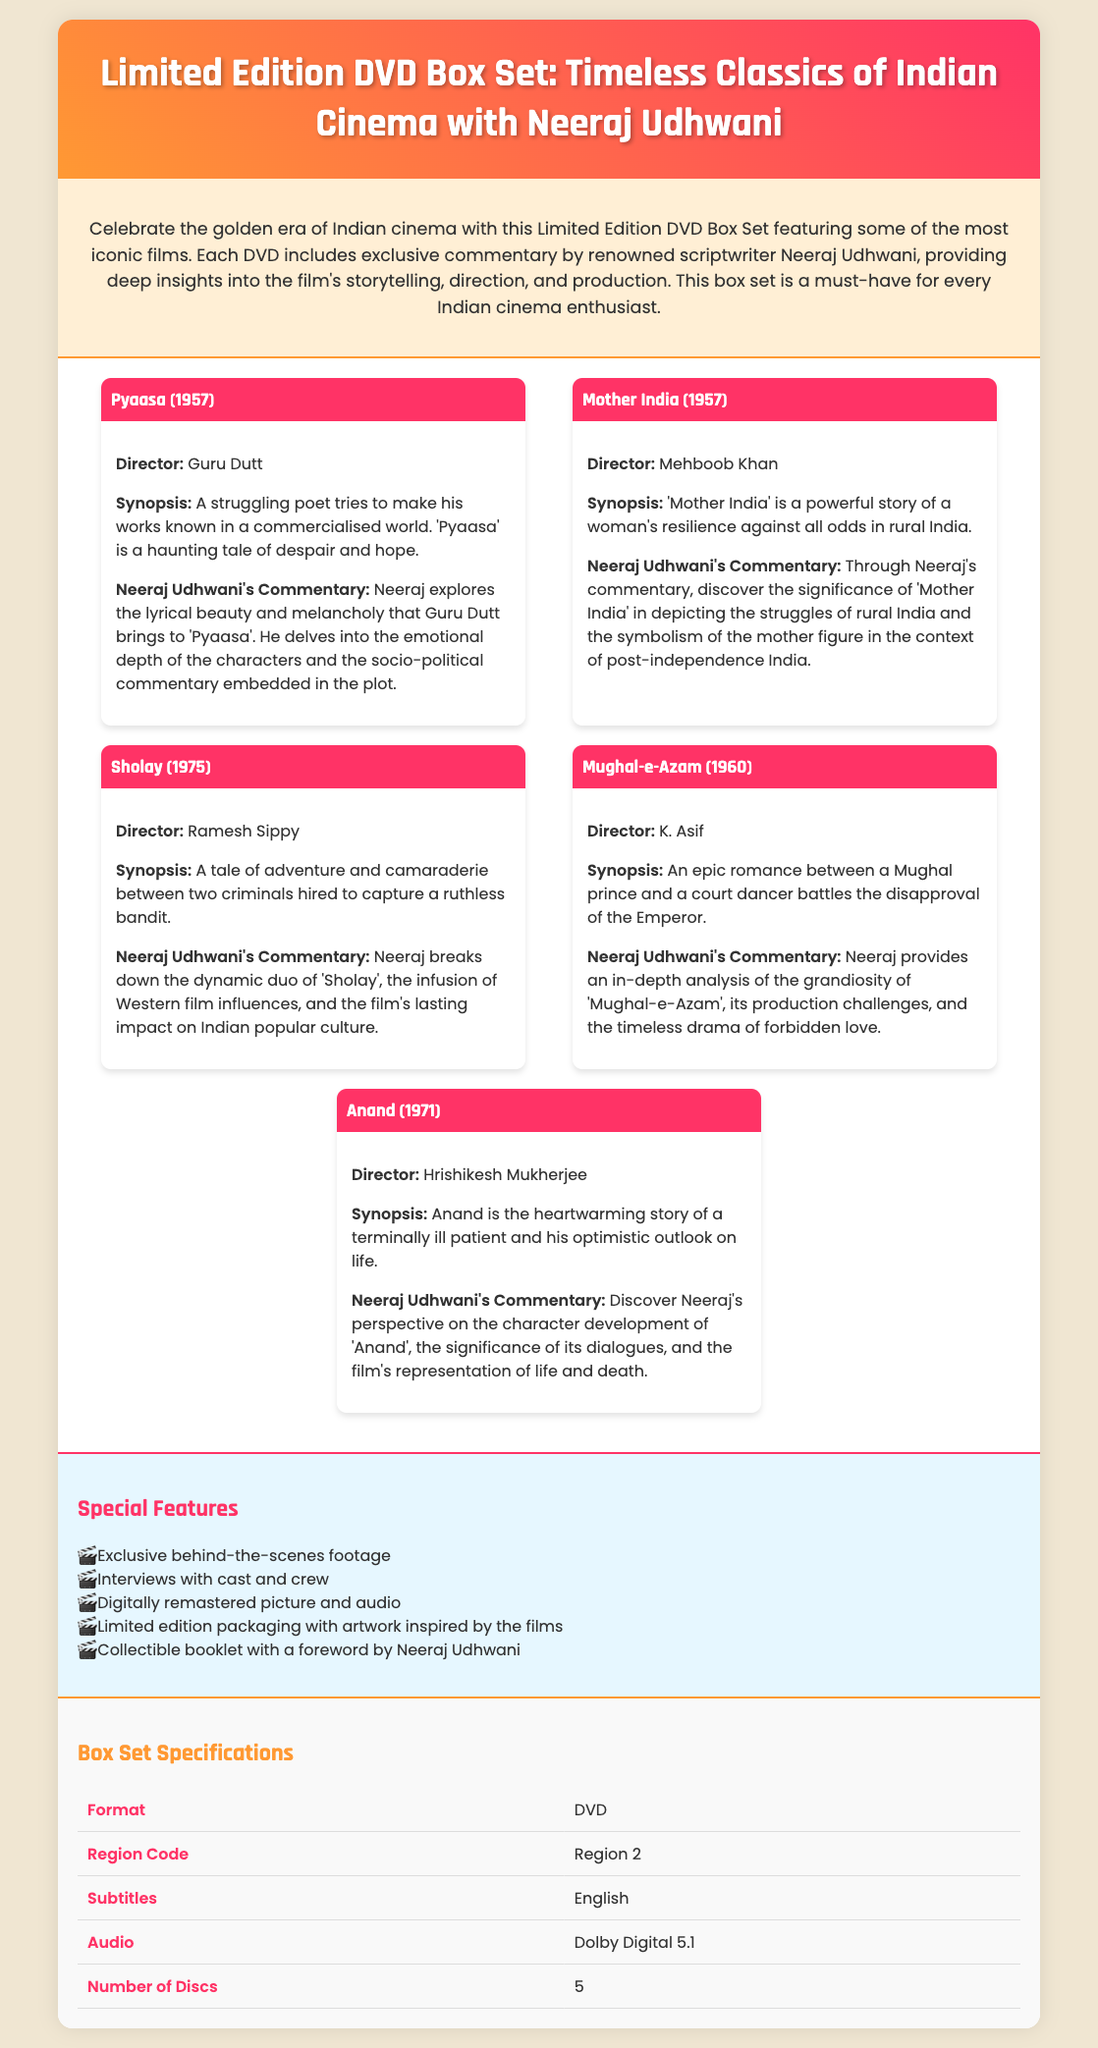What is the title of the DVD box set? The title of the box set is highlights in the header of the document.
Answer: Limited Edition DVD Box Set: Timeless Classics of Indian Cinema with Neeraj Udhwani Who provides commentary on the films? The commentary is highlighted in the product description and individual film sections.
Answer: Neeraj Udhwani How many films are included in the DVD box set? The number of films is evident from the list of films displayed in the document.
Answer: 5 What year was "Pyaasa" released? The release year is specified in the film description of "Pyaasa".
Answer: 1957 What audio format is available in the box set? The audio format is mentioned under the specifications section of the document.
Answer: Dolby Digital 5.1 What is one of the special features included? Special features are listed in the dedicated section of the document.
Answer: Exclusive behind-the-scenes footage What type of packaging does the box set have? The packaging type is described in the special features part of the document.
Answer: Limited edition packaging with artwork inspired by the films Which film's director is Guru Dutt? The director's name is specific to the film "Pyaasa" listed within the film details.
Answer: Pyaasa How many discs are included in the box set? The number of discs is listed clearly in the specifications section.
Answer: 5 